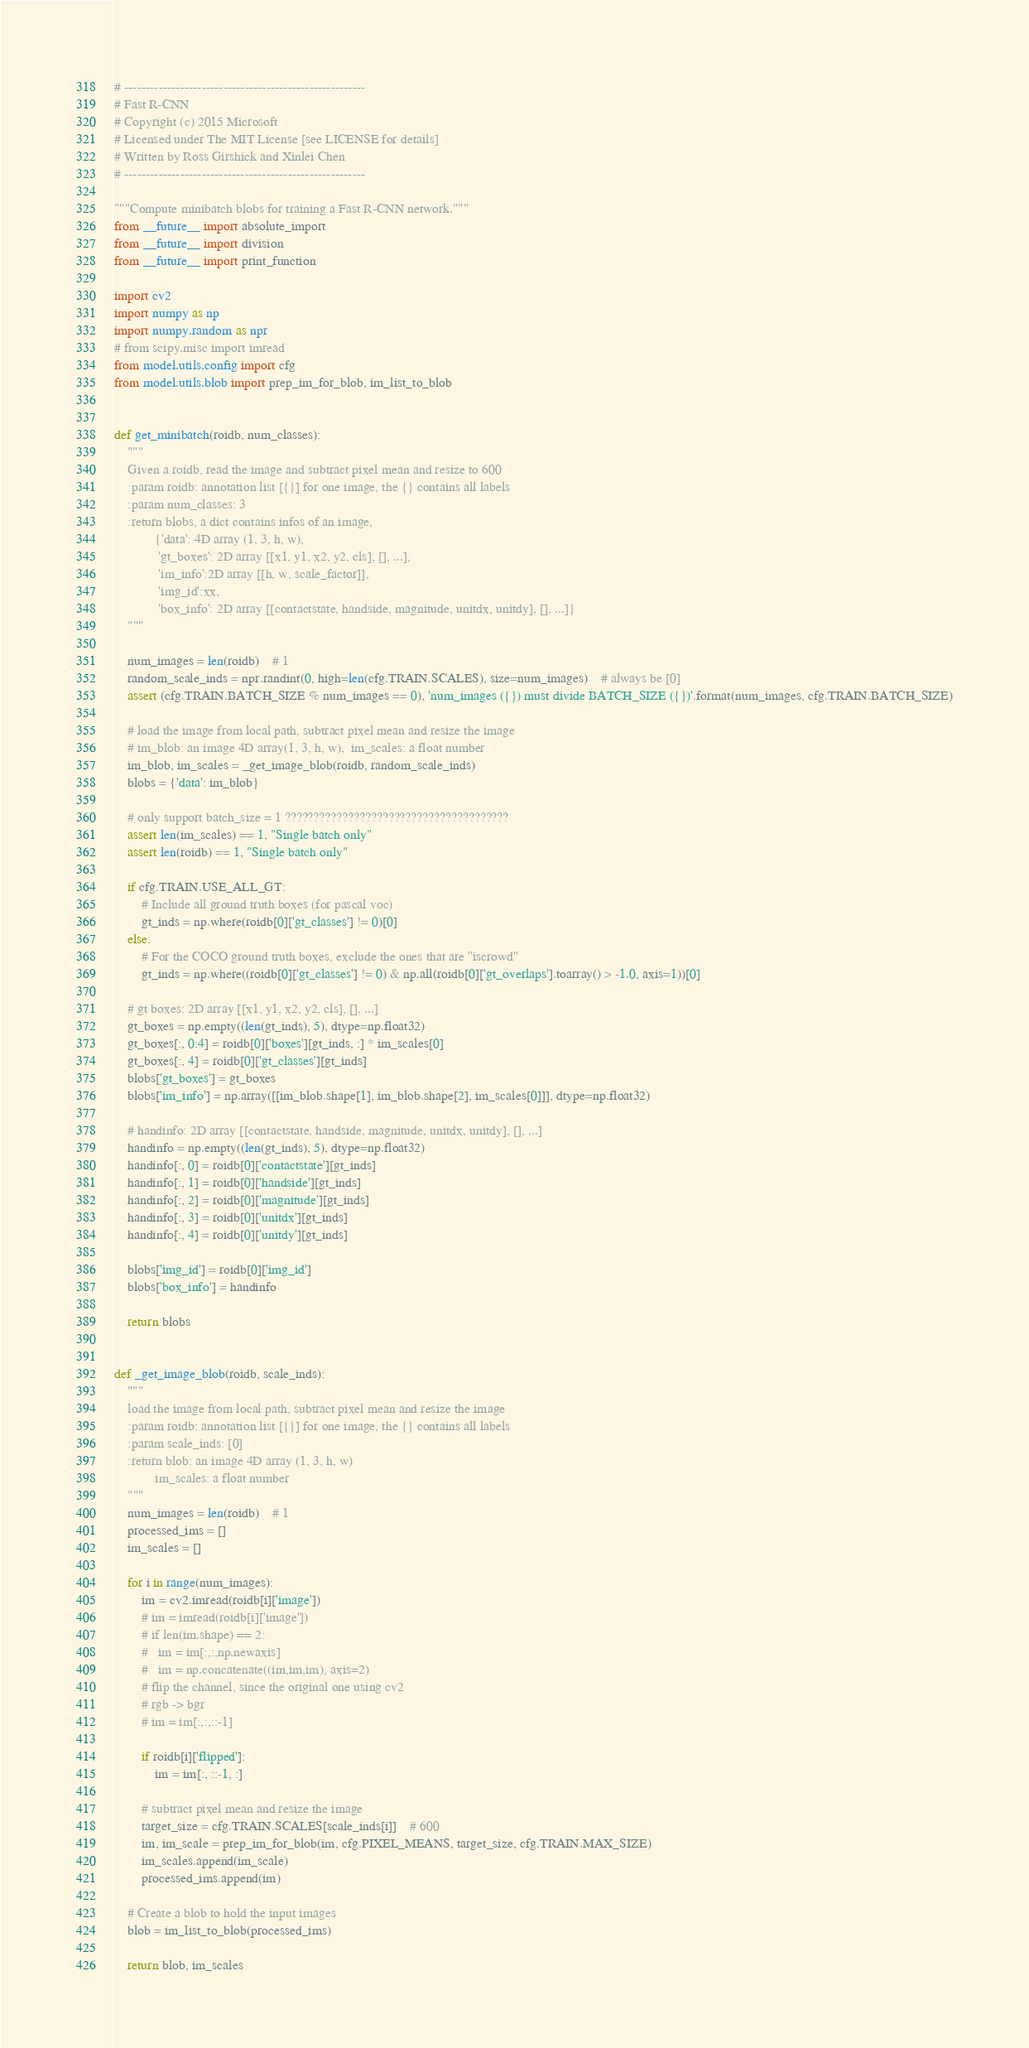Convert code to text. <code><loc_0><loc_0><loc_500><loc_500><_Python_># --------------------------------------------------------
# Fast R-CNN
# Copyright (c) 2015 Microsoft
# Licensed under The MIT License [see LICENSE for details]
# Written by Ross Girshick and Xinlei Chen
# --------------------------------------------------------

"""Compute minibatch blobs for training a Fast R-CNN network."""
from __future__ import absolute_import
from __future__ import division
from __future__ import print_function

import cv2
import numpy as np
import numpy.random as npr
# from scipy.misc import imread
from model.utils.config import cfg
from model.utils.blob import prep_im_for_blob, im_list_to_blob


def get_minibatch(roidb, num_classes):
    """
    Given a roidb, read the image and subtract pixel mean and resize to 600
    :param roidb: annotation list [{}] for one image, the {} contains all labels
    :param num_classes: 3
    :return blobs, a dict contains infos of an image,
            {'data': 4D array (1, 3, h, w),
             'gt_boxes': 2D array [[x1, y1, x2, y2, cls], [], ...],
             'im_info':2D array [[h, w, scale_factor]],
             'img_id':xx,
             'box_info': 2D array [[contactstate, handside, magnitude, unitdx, unitdy], [], ...]}
    """

    num_images = len(roidb)    # 1
    random_scale_inds = npr.randint(0, high=len(cfg.TRAIN.SCALES), size=num_images)    # always be [0]
    assert (cfg.TRAIN.BATCH_SIZE % num_images == 0), 'num_images ({}) must divide BATCH_SIZE ({})'.format(num_images, cfg.TRAIN.BATCH_SIZE)

    # load the image from local path, subtract pixel mean and resize the image
    # im_blob: an image 4D array(1, 3, h, w),  im_scales: a float number
    im_blob, im_scales = _get_image_blob(roidb, random_scale_inds)
    blobs = {'data': im_blob}

    # only support batch_size = 1 ???????????????????????????????????????
    assert len(im_scales) == 1, "Single batch only"
    assert len(roidb) == 1, "Single batch only"

    if cfg.TRAIN.USE_ALL_GT:
        # Include all ground truth boxes (for pascal voc)
        gt_inds = np.where(roidb[0]['gt_classes'] != 0)[0]
    else:
        # For the COCO ground truth boxes, exclude the ones that are ''iscrowd''
        gt_inds = np.where((roidb[0]['gt_classes'] != 0) & np.all(roidb[0]['gt_overlaps'].toarray() > -1.0, axis=1))[0]

    # gt boxes: 2D array [[x1, y1, x2, y2, cls], [], ...]
    gt_boxes = np.empty((len(gt_inds), 5), dtype=np.float32)
    gt_boxes[:, 0:4] = roidb[0]['boxes'][gt_inds, :] * im_scales[0]
    gt_boxes[:, 4] = roidb[0]['gt_classes'][gt_inds]
    blobs['gt_boxes'] = gt_boxes
    blobs['im_info'] = np.array([[im_blob.shape[1], im_blob.shape[2], im_scales[0]]], dtype=np.float32)

    # handinfo: 2D array [[contactstate, handside, magnitude, unitdx, unitdy], [], ...]
    handinfo = np.empty((len(gt_inds), 5), dtype=np.float32)
    handinfo[:, 0] = roidb[0]['contactstate'][gt_inds]
    handinfo[:, 1] = roidb[0]['handside'][gt_inds]
    handinfo[:, 2] = roidb[0]['magnitude'][gt_inds]
    handinfo[:, 3] = roidb[0]['unitdx'][gt_inds]
    handinfo[:, 4] = roidb[0]['unitdy'][gt_inds]

    blobs['img_id'] = roidb[0]['img_id']
    blobs['box_info'] = handinfo

    return blobs


def _get_image_blob(roidb, scale_inds):
    """
    load the image from local path, subtract pixel mean and resize the image
    :param roidb: annotation list [{}] for one image, the {} contains all labels
    :param scale_inds: [0]
    :return blob: an image 4D array (1, 3, h, w)
            im_scales: a float number
    """
    num_images = len(roidb)    # 1
    processed_ims = []
    im_scales = []

    for i in range(num_images):
        im = cv2.imread(roidb[i]['image'])
        # im = imread(roidb[i]['image'])
        # if len(im.shape) == 2:
        #   im = im[:,:,np.newaxis]
        #   im = np.concatenate((im,im,im), axis=2)
        # flip the channel, since the original one using cv2
        # rgb -> bgr
        # im = im[:,:,::-1]

        if roidb[i]['flipped']:
            im = im[:, ::-1, :]

        # subtract pixel mean and resize the image
        target_size = cfg.TRAIN.SCALES[scale_inds[i]]    # 600
        im, im_scale = prep_im_for_blob(im, cfg.PIXEL_MEANS, target_size, cfg.TRAIN.MAX_SIZE)
        im_scales.append(im_scale)
        processed_ims.append(im)

    # Create a blob to hold the input images
    blob = im_list_to_blob(processed_ims)

    return blob, im_scales
</code> 